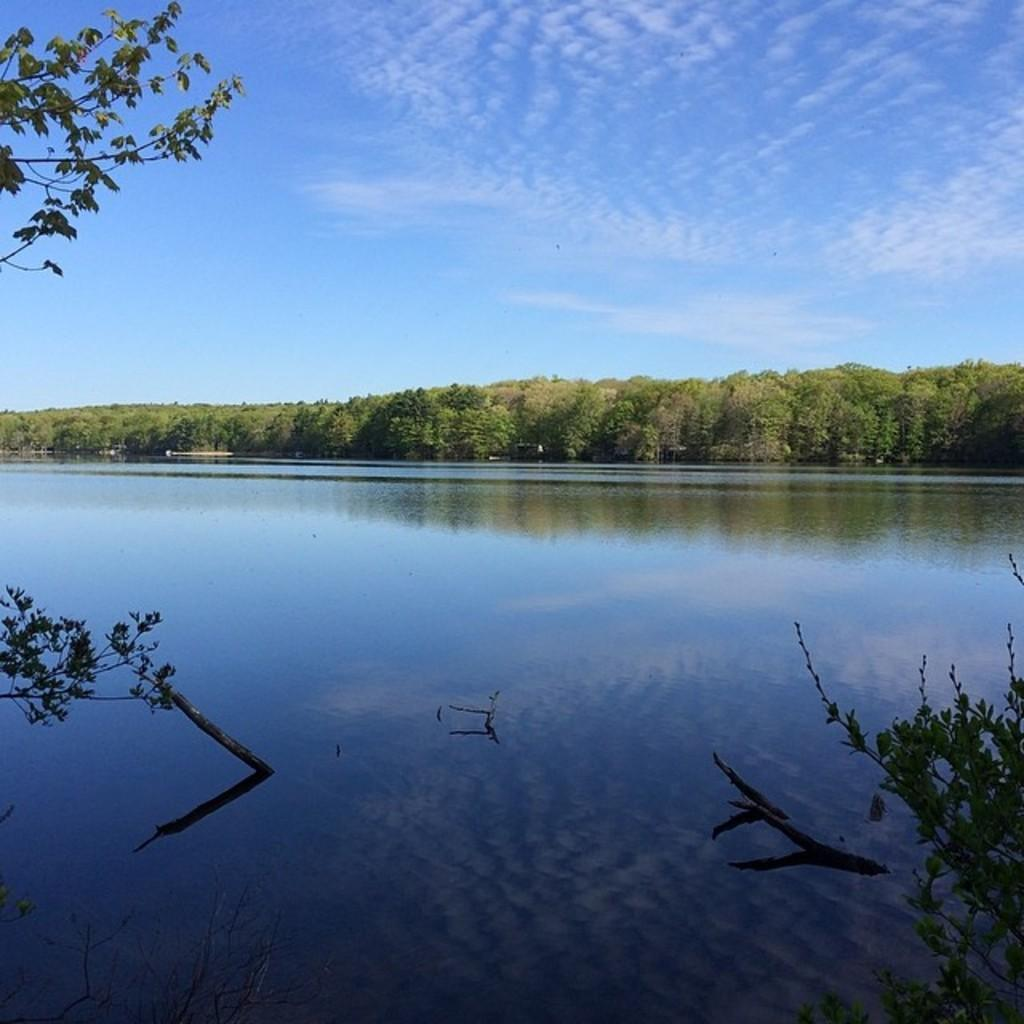What type of natural body of water is present in the image? There is a lake in the image. What type of vegetation can be seen in the background of the image? There are trees in the background of the image. What is visible in the background of the image besides the trees? The sky is visible in the background of the image. What type of watch is floating on the lake in the image? There is no watch present in the image; it only features a lake, trees, and the sky. What type of quiver can be seen hanging from the trees in the image? There is no quiver present in the image; it only features a lake, trees, and the sky. 